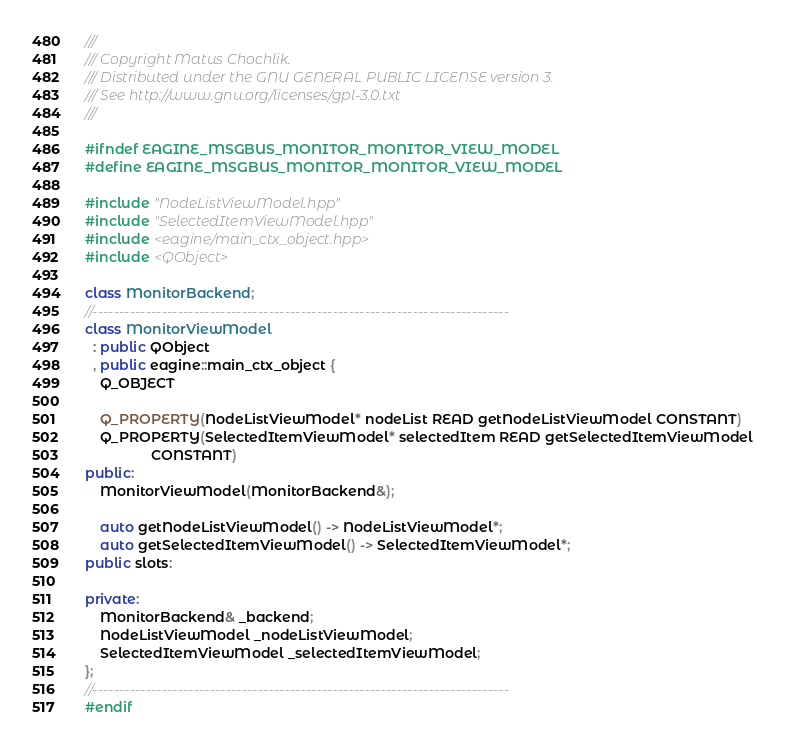<code> <loc_0><loc_0><loc_500><loc_500><_C++_>///
/// Copyright Matus Chochlik.
/// Distributed under the GNU GENERAL PUBLIC LICENSE version 3.
/// See http://www.gnu.org/licenses/gpl-3.0.txt
///

#ifndef EAGINE_MSGBUS_MONITOR_MONITOR_VIEW_MODEL
#define EAGINE_MSGBUS_MONITOR_MONITOR_VIEW_MODEL

#include "NodeListViewModel.hpp"
#include "SelectedItemViewModel.hpp"
#include <eagine/main_ctx_object.hpp>
#include <QObject>

class MonitorBackend;
//------------------------------------------------------------------------------
class MonitorViewModel
  : public QObject
  , public eagine::main_ctx_object {
    Q_OBJECT

    Q_PROPERTY(NodeListViewModel* nodeList READ getNodeListViewModel CONSTANT)
    Q_PROPERTY(SelectedItemViewModel* selectedItem READ getSelectedItemViewModel
                 CONSTANT)
public:
    MonitorViewModel(MonitorBackend&);

    auto getNodeListViewModel() -> NodeListViewModel*;
    auto getSelectedItemViewModel() -> SelectedItemViewModel*;
public slots:

private:
    MonitorBackend& _backend;
    NodeListViewModel _nodeListViewModel;
    SelectedItemViewModel _selectedItemViewModel;
};
//------------------------------------------------------------------------------
#endif
</code> 